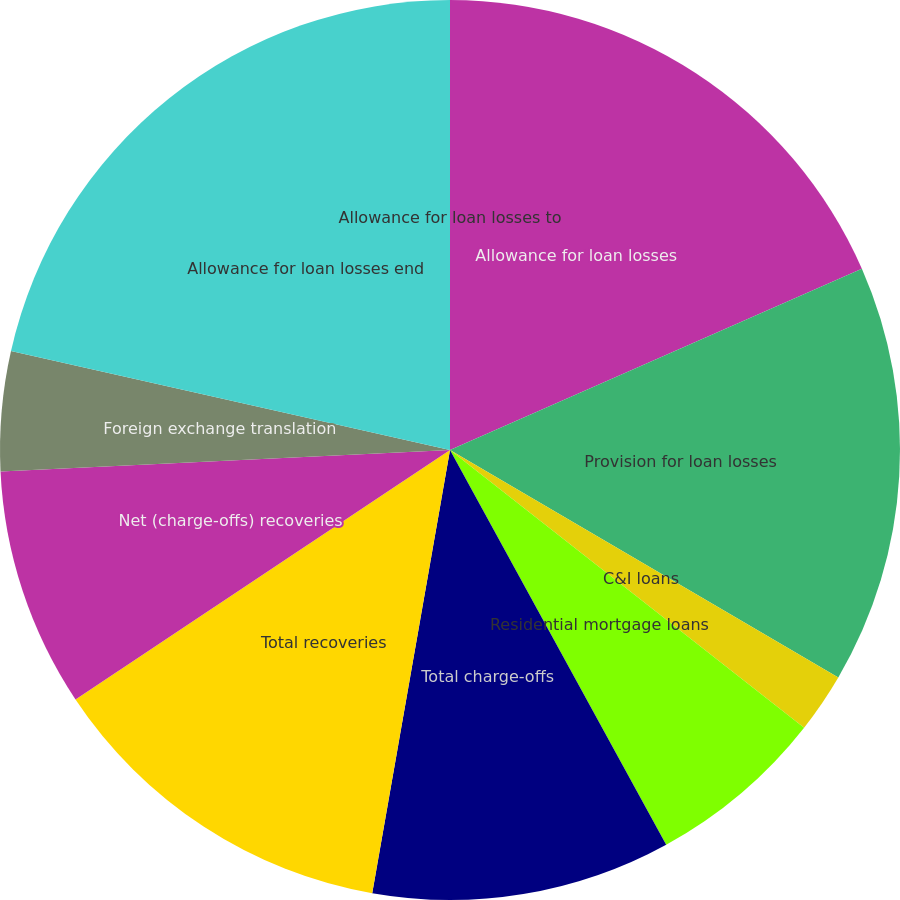Convert chart to OTSL. <chart><loc_0><loc_0><loc_500><loc_500><pie_chart><fcel>Allowance for loan losses<fcel>Provision for loan losses<fcel>C&I loans<fcel>Residential mortgage loans<fcel>Total charge-offs<fcel>Total recoveries<fcel>Net (charge-offs) recoveries<fcel>Foreign exchange translation<fcel>Allowance for loan losses end<fcel>Allowance for loan losses to<nl><fcel>18.4%<fcel>15.03%<fcel>2.15%<fcel>6.44%<fcel>10.74%<fcel>12.88%<fcel>8.59%<fcel>4.29%<fcel>21.47%<fcel>0.0%<nl></chart> 